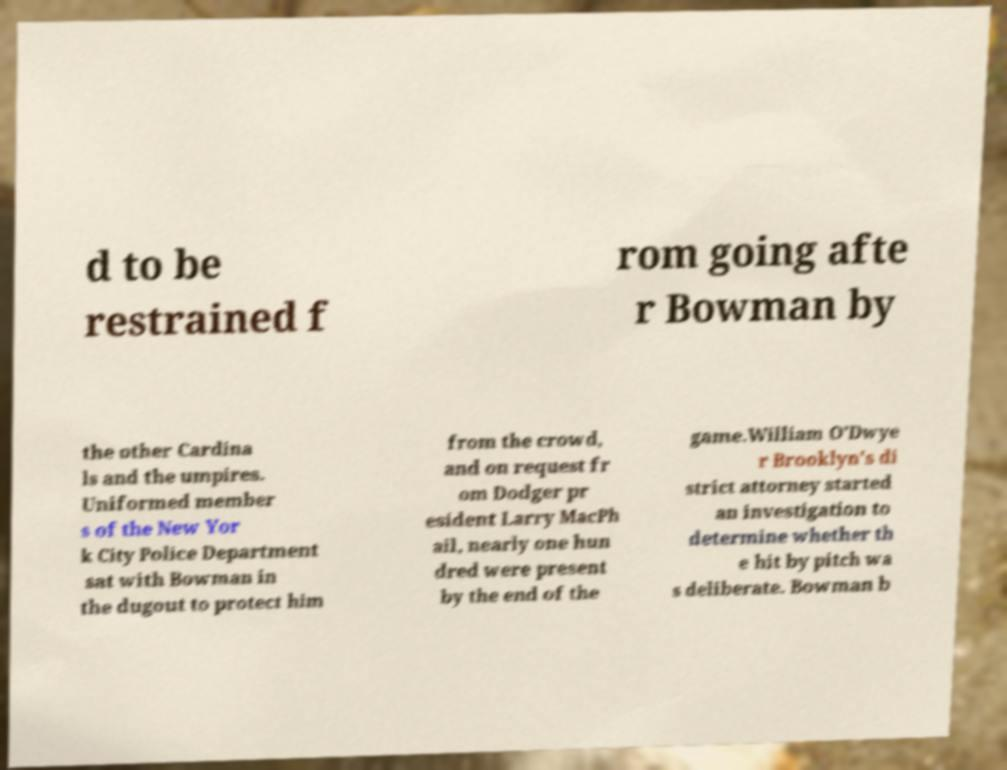Could you assist in decoding the text presented in this image and type it out clearly? d to be restrained f rom going afte r Bowman by the other Cardina ls and the umpires. Uniformed member s of the New Yor k City Police Department sat with Bowman in the dugout to protect him from the crowd, and on request fr om Dodger pr esident Larry MacPh ail, nearly one hun dred were present by the end of the game.William O'Dwye r Brooklyn's di strict attorney started an investigation to determine whether th e hit by pitch wa s deliberate. Bowman b 